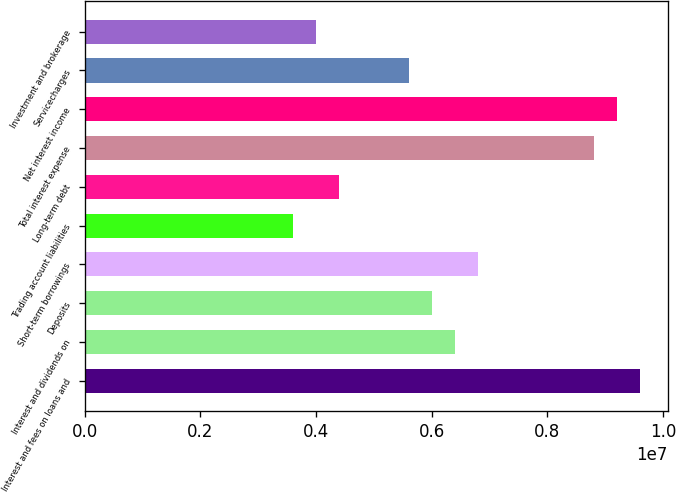Convert chart to OTSL. <chart><loc_0><loc_0><loc_500><loc_500><bar_chart><fcel>Interest and fees on loans and<fcel>Interest and dividends on<fcel>Deposits<fcel>Short-term borrowings<fcel>Trading account liabilities<fcel>Long-term debt<fcel>Total interest expense<fcel>Net interest income<fcel>Servicecharges<fcel>Investment and brokerage<nl><fcel>9.60137e+06<fcel>6.40092e+06<fcel>6.00086e+06<fcel>6.80097e+06<fcel>3.60052e+06<fcel>4.40063e+06<fcel>8.80126e+06<fcel>9.20132e+06<fcel>5.6008e+06<fcel>4.00057e+06<nl></chart> 